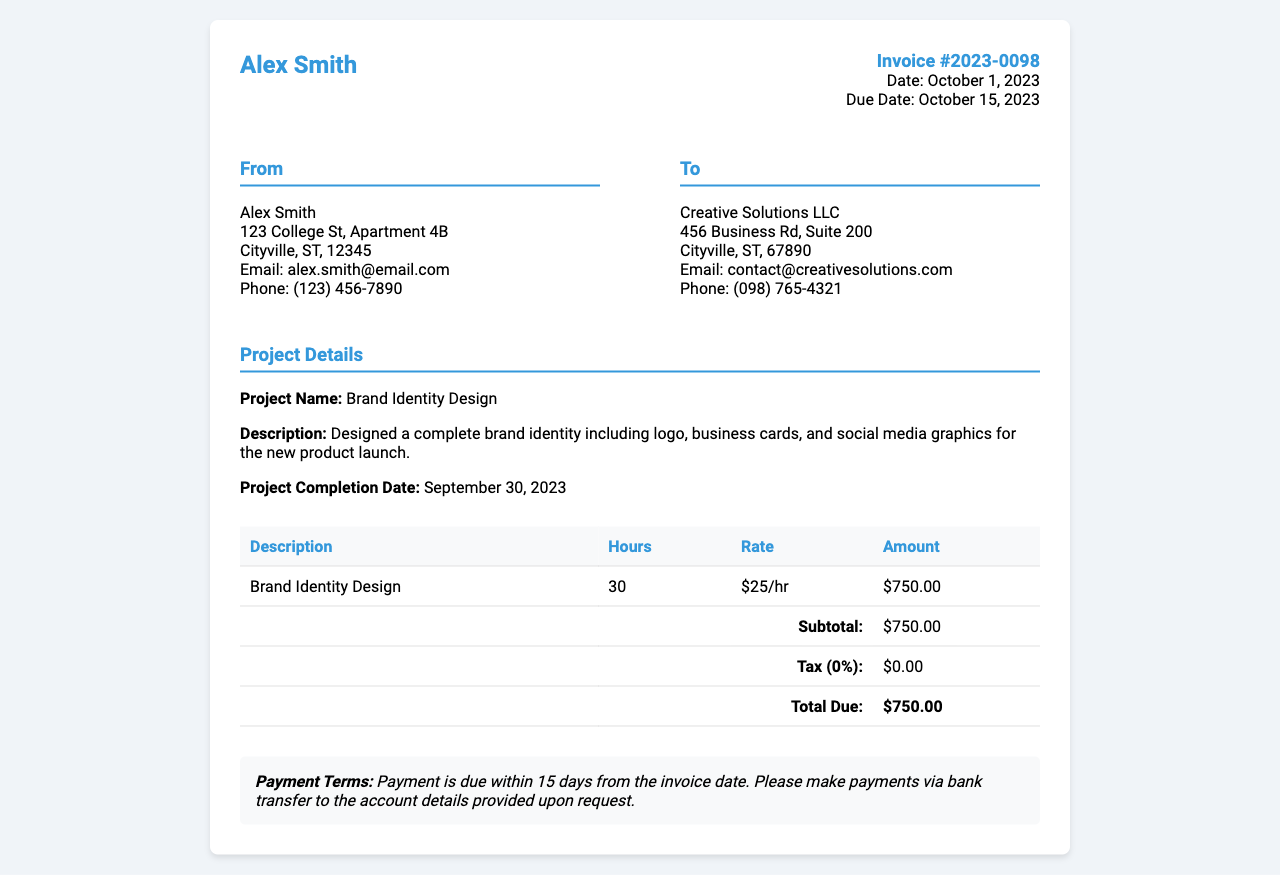What is the invoice number? The invoice number is uniquely identifying this billing document, found at the top right of the invoice.
Answer: 2023-0098 What is the total amount due? The total amount due is the total calculated after adding any line items and tax, provided at the bottom of the invoice.
Answer: $750.00 Who is the graphic designer? The graphic designer's name is at the top left of the invoice, indicating the service provider for this work.
Answer: Alex Smith What is the project completion date? The project completion date is specified in the project details section, indicating when the work was finished.
Answer: September 30, 2023 How many hours were worked on the project? The hours worked are listed in the table among the services rendered, showing the time spent on the project.
Answer: 30 What is the payment due date? The payment due date is specified on the invoice and indicates when the payment should be made.
Answer: October 15, 2023 What type of service was provided? The type of service is outlined under project details, describing the nature of the work done for the client.
Answer: Brand Identity Design What was the rate charged per hour? The rate charged per hour is mentioned in the invoice, showing how the total amount was calculated from billable hours.
Answer: $25/hr Who is the client? The client's name and contact details are listed in the 'To' section of the invoice, identifying the recipient of services.
Answer: Creative Solutions LLC 